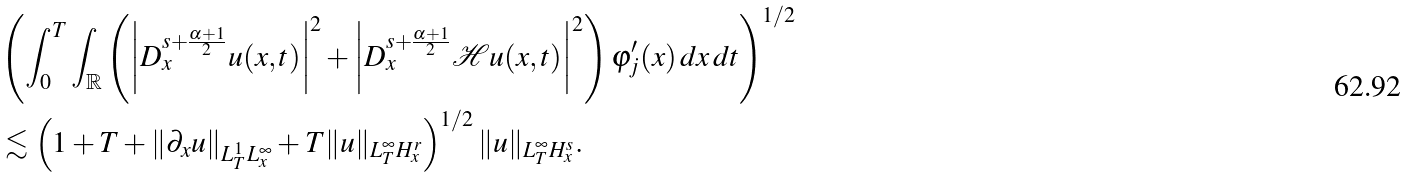<formula> <loc_0><loc_0><loc_500><loc_500>& \left ( \int _ { 0 } ^ { T } \int _ { \mathbb { R } } \left ( \left | D _ { x } ^ { s + \frac { \alpha + 1 } { 2 } } u ( x , t ) \right | ^ { 2 } + \left | D _ { x } ^ { s + \frac { \alpha + 1 } { 2 } } \mathcal { H } u ( x , t ) \right | ^ { 2 } \right ) \varphi ^ { \prime } _ { j } ( x ) \, d x \, d t \right ) ^ { 1 / 2 } \\ & \lesssim \left ( 1 + T + \| \partial _ { x } u \| _ { L ^ { 1 } _ { T } L ^ { \infty } _ { x } } + T \| u \| _ { L ^ { \infty } _ { T } H ^ { r } _ { x } } \right ) ^ { 1 / 2 } \| u \| _ { L ^ { \infty } _ { T } H ^ { s } _ { x } } .</formula> 